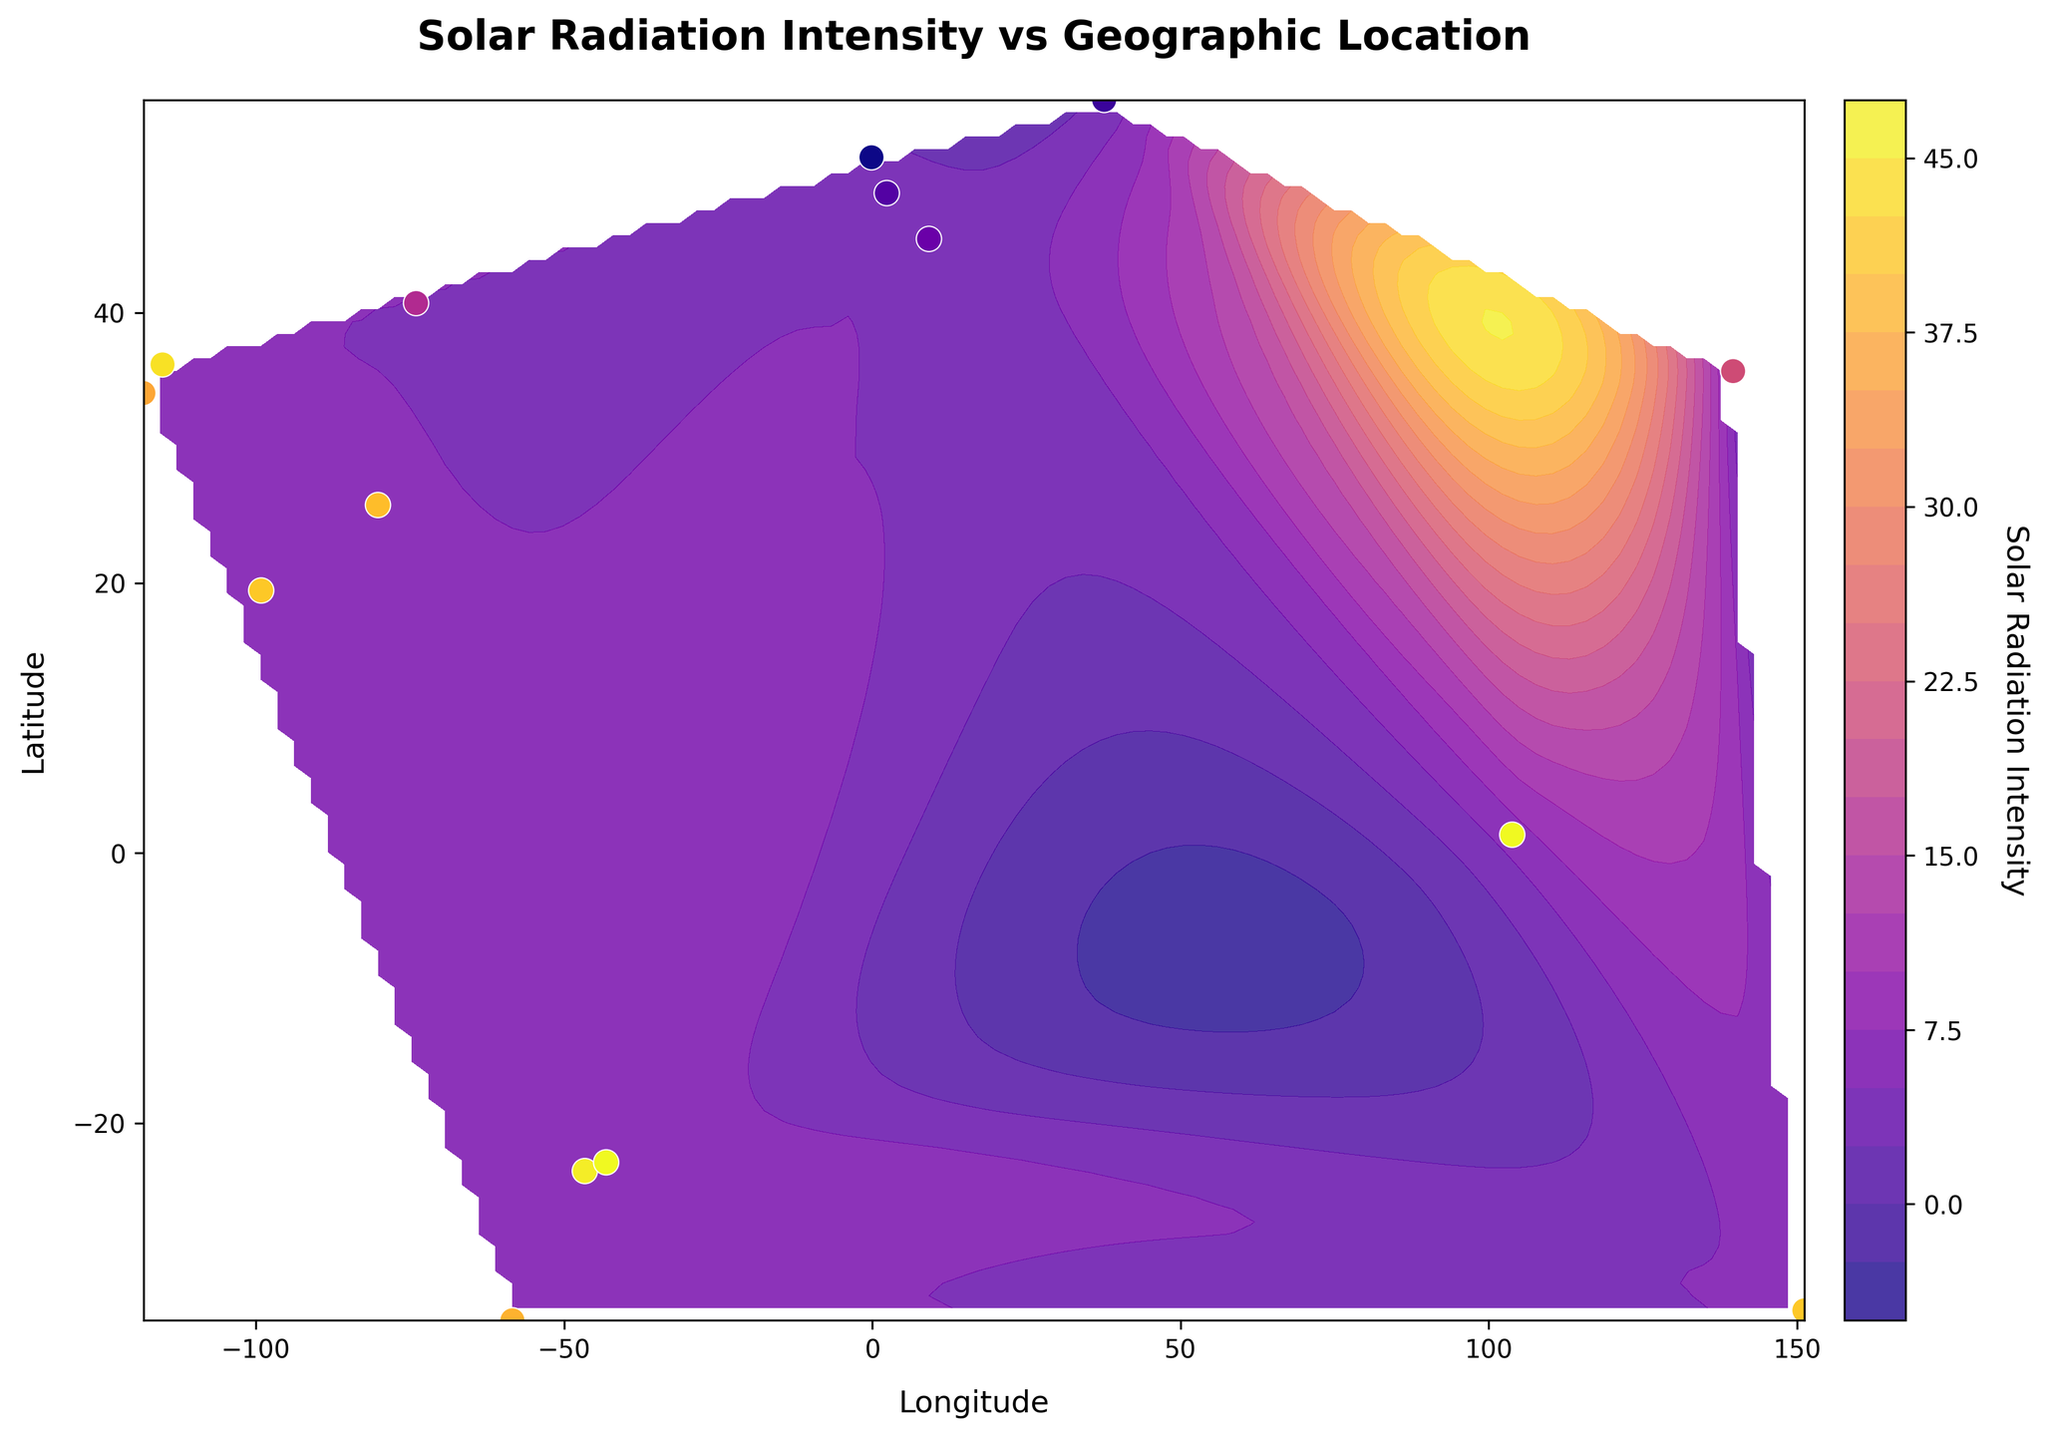What's the title of this plot? The title of the plot is typically placed at the top of the figure. By looking at the figure, one can read the text on the plot and identify the title.
Answer: Solar Radiation Intensity vs Geographic Location What are the units on the x-axis and y-axis of the plot? To find the units of the x and y-axis, one should look at the labels on both axes. The x-axis is labeled "Longitude" and the y-axis is labeled "Latitude," indicating these are the units.
Answer: Longitude and Latitude How many data points are plotted on the scatter plot? Each data point corresponds to a location where solar radiation intensity has been measured. By counting the white-edged dots on the scatter plot, one finds that there are 16 data points.
Answer: 16 Which geographic location has the highest solar radiation intensity? By inspecting the scatter points color-coded by solar radiation intensity and matching the highest value on the color scale, the point with the highest intensity can be identified which is near Singapore at latitude 1.3521 and longitude 103.8198.
Answer: Singapore Is there a general trend in solar radiation intensity across different latitudes? This requires analyzing the overall pattern of the contour plot. Generally, the color gradient suggests that higher solar radiation intensity is observed near the equator and decreases towards the poles.
Answer: Higher near the equator, decreases towards the poles Which location in the US has the highest solar radiation intensity? Three locations in the US are identified: Los Angeles, Las Vegas, and New York City. By comparing the color and intensity values, Las Vegas shows a higher intensity of 6.1.
Answer: Las Vegas Compare the solar radiation intensity between Tokyo and Rio de Janeiro. Which one is higher? Looking at the scatter points for Tokyo (intensity ~4.5-4.6) and Rio de Janeiro (intensity ~6.3), it is clear from the color scale and intensity values that Rio de Janeiro has a higher solar radiation intensity.
Answer: Rio de Janeiro What's the range of solar radiation intensity values shown in the color bar? The color bar next to the contour plot indicates the range of solar radiation intensities visualized in the plot. The range goes from around 2.8 to 6.3.
Answer: 2.8 to 6.3 Approximately what is the average solar radiation intensity for the locations shown? To estimate, identify the intensities for each location and calculate the average: (5.6 + 6.1 + 4.2 + 5.8 + 2.8 + 4.5 + 5.9 + 3.1 + 3.3 + 4.6 + 6.2 + 6.3 + 5.9 + 5.7 + 6.3 + 3.5) / 16 = 4.97.
Answer: 4.97 What does the color yellow represent on the contour plot? By referring to the color bar on the side of the plot, the color yellow typically represents higher solar radiation intensity values, around 6.0 and above.
Answer: High solar radiation 